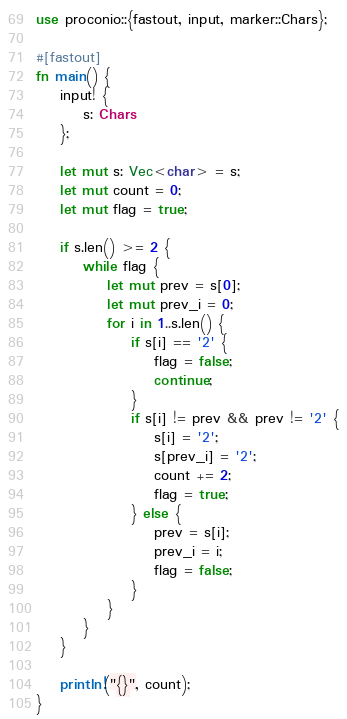<code> <loc_0><loc_0><loc_500><loc_500><_Rust_>use proconio::{fastout, input, marker::Chars};

#[fastout]
fn main() {
    input! {
        s: Chars
    };

    let mut s: Vec<char> = s;
    let mut count = 0;
    let mut flag = true;

    if s.len() >= 2 {
        while flag {
            let mut prev = s[0];
            let mut prev_i = 0;
            for i in 1..s.len() {
                if s[i] == '2' {
                    flag = false;
                    continue;
                }
                if s[i] != prev && prev != '2' {
                    s[i] = '2';
                    s[prev_i] = '2';
                    count += 2;
                    flag = true;
                } else {
                    prev = s[i];
                    prev_i = i;
                    flag = false;
                }
            }
        }
    }

    println!("{}", count);
}
</code> 